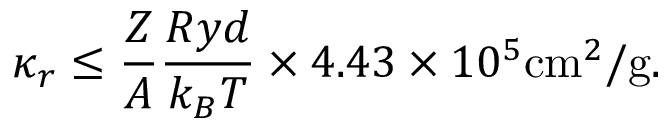<formula> <loc_0><loc_0><loc_500><loc_500>\kappa _ { r } \leq \frac { Z } { A } \frac { R y d } { k _ { B } T } \times 4 . 4 3 \times 1 0 ^ { 5 } c m ^ { 2 } / g .</formula> 